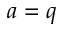Convert formula to latex. <formula><loc_0><loc_0><loc_500><loc_500>a = q</formula> 